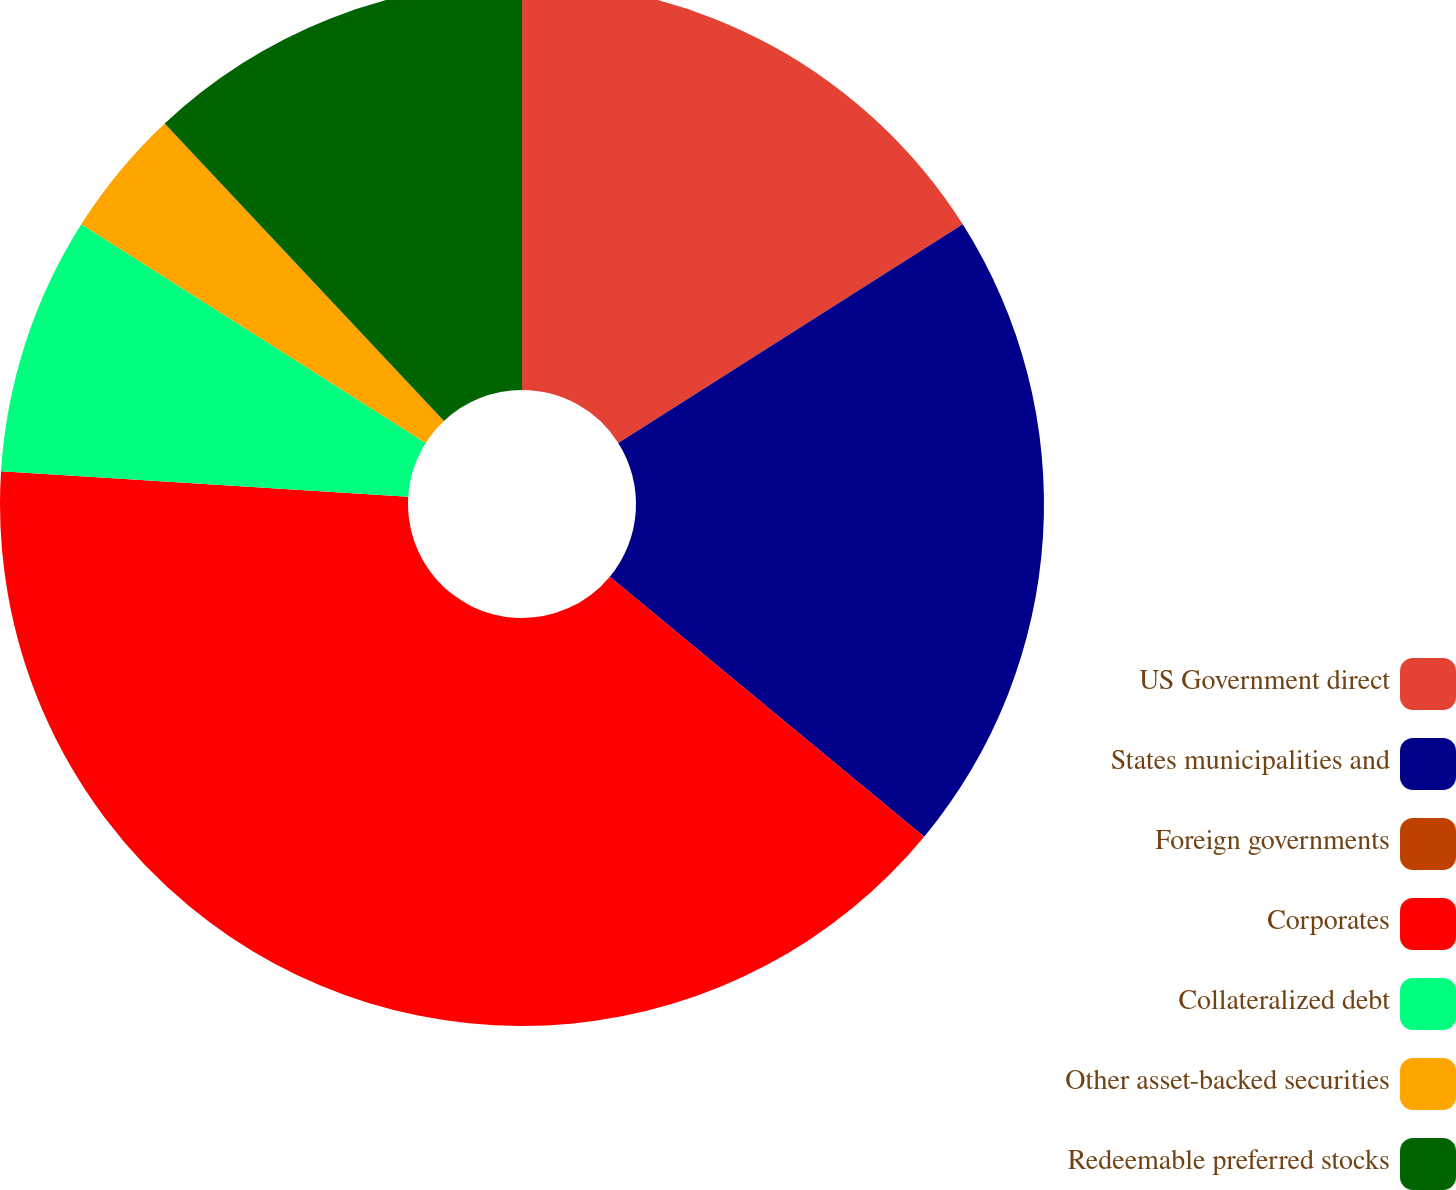<chart> <loc_0><loc_0><loc_500><loc_500><pie_chart><fcel>US Government direct<fcel>States municipalities and<fcel>Foreign governments<fcel>Corporates<fcel>Collateralized debt<fcel>Other asset-backed securities<fcel>Redeemable preferred stocks<nl><fcel>16.0%<fcel>20.0%<fcel>0.0%<fcel>40.0%<fcel>8.0%<fcel>4.0%<fcel>12.0%<nl></chart> 